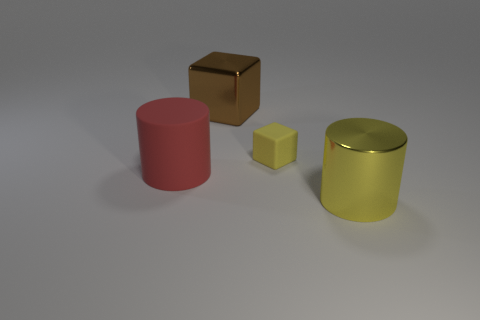What can you infer about the physical properties of the objects in the image? All objects in the image appear to have a smooth texture and are likely made of metal, indicated by their reflective surfaces. The red cylinder and yellow cylinder seem to have matte finishes, while the brown cube and small yellow cube have a glossier appearance. If the objects were to be weighed, which do you think would be the heaviest? Assuming all objects are made of the same material, the yellow cylinder would likely be the heaviest due to its larger size, which suggests a greater volume and, therefore, more material contributing to its weight. 